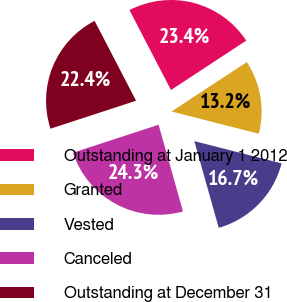Convert chart. <chart><loc_0><loc_0><loc_500><loc_500><pie_chart><fcel>Outstanding at January 1 2012<fcel>Granted<fcel>Vested<fcel>Canceled<fcel>Outstanding at December 31<nl><fcel>23.37%<fcel>13.22%<fcel>16.66%<fcel>24.34%<fcel>22.4%<nl></chart> 